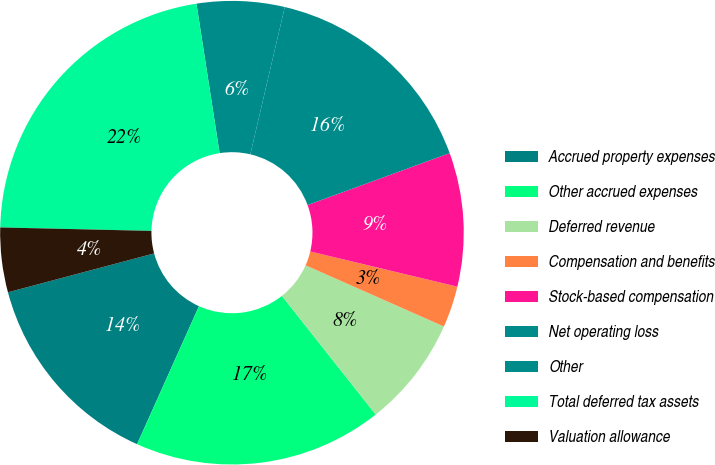Convert chart to OTSL. <chart><loc_0><loc_0><loc_500><loc_500><pie_chart><fcel>Accrued property expenses<fcel>Other accrued expenses<fcel>Deferred revenue<fcel>Compensation and benefits<fcel>Stock-based compensation<fcel>Net operating loss<fcel>Other<fcel>Total deferred tax assets<fcel>Valuation allowance<nl><fcel>14.15%<fcel>17.36%<fcel>7.72%<fcel>2.89%<fcel>9.32%<fcel>15.76%<fcel>6.11%<fcel>22.19%<fcel>4.5%<nl></chart> 